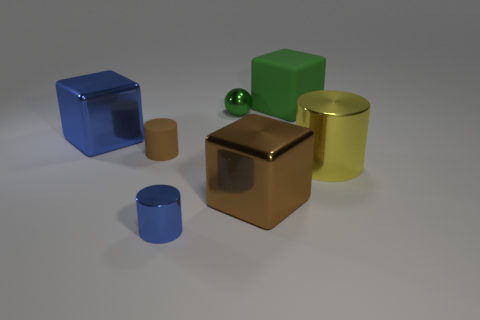There is a block that is on the right side of the big blue metal thing and in front of the green sphere; what size is it?
Your response must be concise. Large. What number of large objects are the same color as the metal sphere?
Offer a very short reply. 1. There is a thing that is the same color as the tiny ball; what is it made of?
Your answer should be very brief. Rubber. What is the big blue thing made of?
Provide a succinct answer. Metal. Is the small cylinder to the right of the tiny brown matte cylinder made of the same material as the small green thing?
Offer a very short reply. Yes. There is a small metallic thing that is in front of the yellow metal object; what is its shape?
Ensure brevity in your answer.  Cylinder. What material is the green ball that is the same size as the blue metal cylinder?
Give a very brief answer. Metal. What number of objects are metal things behind the tiny matte object or metallic cylinders that are to the right of the brown shiny object?
Ensure brevity in your answer.  3. There is another blue thing that is made of the same material as the tiny blue object; what is its size?
Provide a short and direct response. Large. What number of metal things are either brown blocks or small blue cylinders?
Keep it short and to the point. 2. 